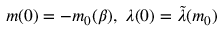<formula> <loc_0><loc_0><loc_500><loc_500>m ( 0 ) = - m _ { 0 } ( \beta ) , \, \lambda ( 0 ) = \tilde { \lambda } ( m _ { 0 } )</formula> 